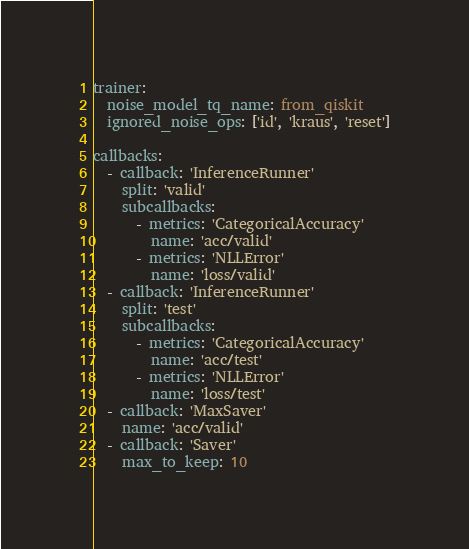<code> <loc_0><loc_0><loc_500><loc_500><_YAML_>trainer:
  noise_model_tq_name: from_qiskit
  ignored_noise_ops: ['id', 'kraus', 'reset']

callbacks:
  - callback: 'InferenceRunner'
    split: 'valid'
    subcallbacks:
      - metrics: 'CategoricalAccuracy'
        name: 'acc/valid'
      - metrics: 'NLLError'
        name: 'loss/valid'
  - callback: 'InferenceRunner'
    split: 'test'
    subcallbacks:
      - metrics: 'CategoricalAccuracy'
        name: 'acc/test'
      - metrics: 'NLLError'
        name: 'loss/test'
  - callback: 'MaxSaver'
    name: 'acc/valid'
  - callback: 'Saver'
    max_to_keep: 10
</code> 